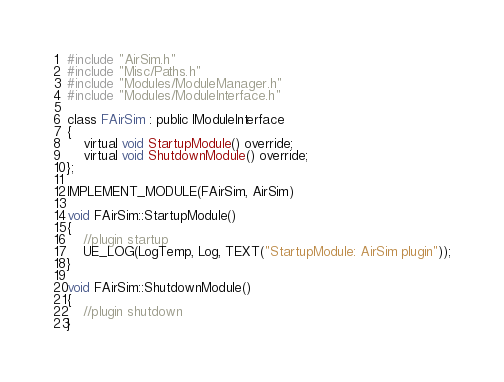Convert code to text. <code><loc_0><loc_0><loc_500><loc_500><_C++_>
#include "AirSim.h"
#include "Misc/Paths.h"
#include "Modules/ModuleManager.h"
#include "Modules/ModuleInterface.h"

class FAirSim : public IModuleInterface
{
    virtual void StartupModule() override;
    virtual void ShutdownModule() override;
};

IMPLEMENT_MODULE(FAirSim, AirSim)

void FAirSim::StartupModule()
{
    //plugin startup
    UE_LOG(LogTemp, Log, TEXT("StartupModule: AirSim plugin"));
}

void FAirSim::ShutdownModule()
{
    //plugin shutdown
}</code> 